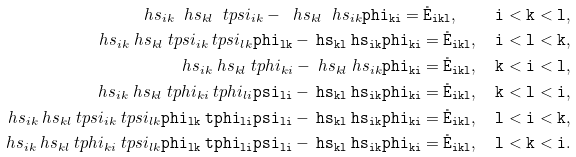Convert formula to latex. <formula><loc_0><loc_0><loc_500><loc_500>\ h s _ { i k } \ h s _ { k l } \ t p s i _ { i k } - \ h s _ { k l } \ h s _ { i k } \tt p h i _ { k i } = \mathring { E } _ { i k l } , \quad i < k < l , \\ \ h s _ { i k } \ h s _ { k l } \ t p s i _ { i k } \ t p s i _ { l k } \tt p h i _ { l k } - \ h s _ { k l } \ h s _ { i k } \tt p h i _ { k i } = \mathring { E } _ { i k l } , \quad i < l < k , \\ \ h s _ { i k } \ h s _ { k l } \ t p h i _ { k i } - \ h s _ { k l } \ h s _ { i k } \tt p h i _ { k i } = \mathring { E } _ { i k l } , \quad k < i < l , \\ \ h s _ { i k } \ h s _ { k l } \ t p h i _ { k i } \ t p h i _ { l i } \tt p s i _ { l i } - \ h s _ { k l } \ h s _ { i k } \tt p h i _ { k i } = \mathring { E } _ { i k l } , \quad k < l < i , \\ \ h s _ { i k } \ h s _ { k l } \ t p s i _ { i k } \ t p s i _ { l k } \tt p h i _ { l k } \ t p h i _ { l i } \tt p s i _ { l i } - \ h s _ { k l } \ h s _ { i k } \tt p h i _ { k i } = \mathring { E } _ { i k l } , \quad l < i < k , \\ \ h s _ { i k } \ h s _ { k l } \ t p h i _ { k i } \ t p s i _ { l k } \tt p h i _ { l k } \ t p h i _ { l i } \tt p s i _ { l i } - \ h s _ { k l } \ h s _ { i k } \tt p h i _ { k i } = \mathring { E } _ { i k l } , \quad l < k < i .</formula> 